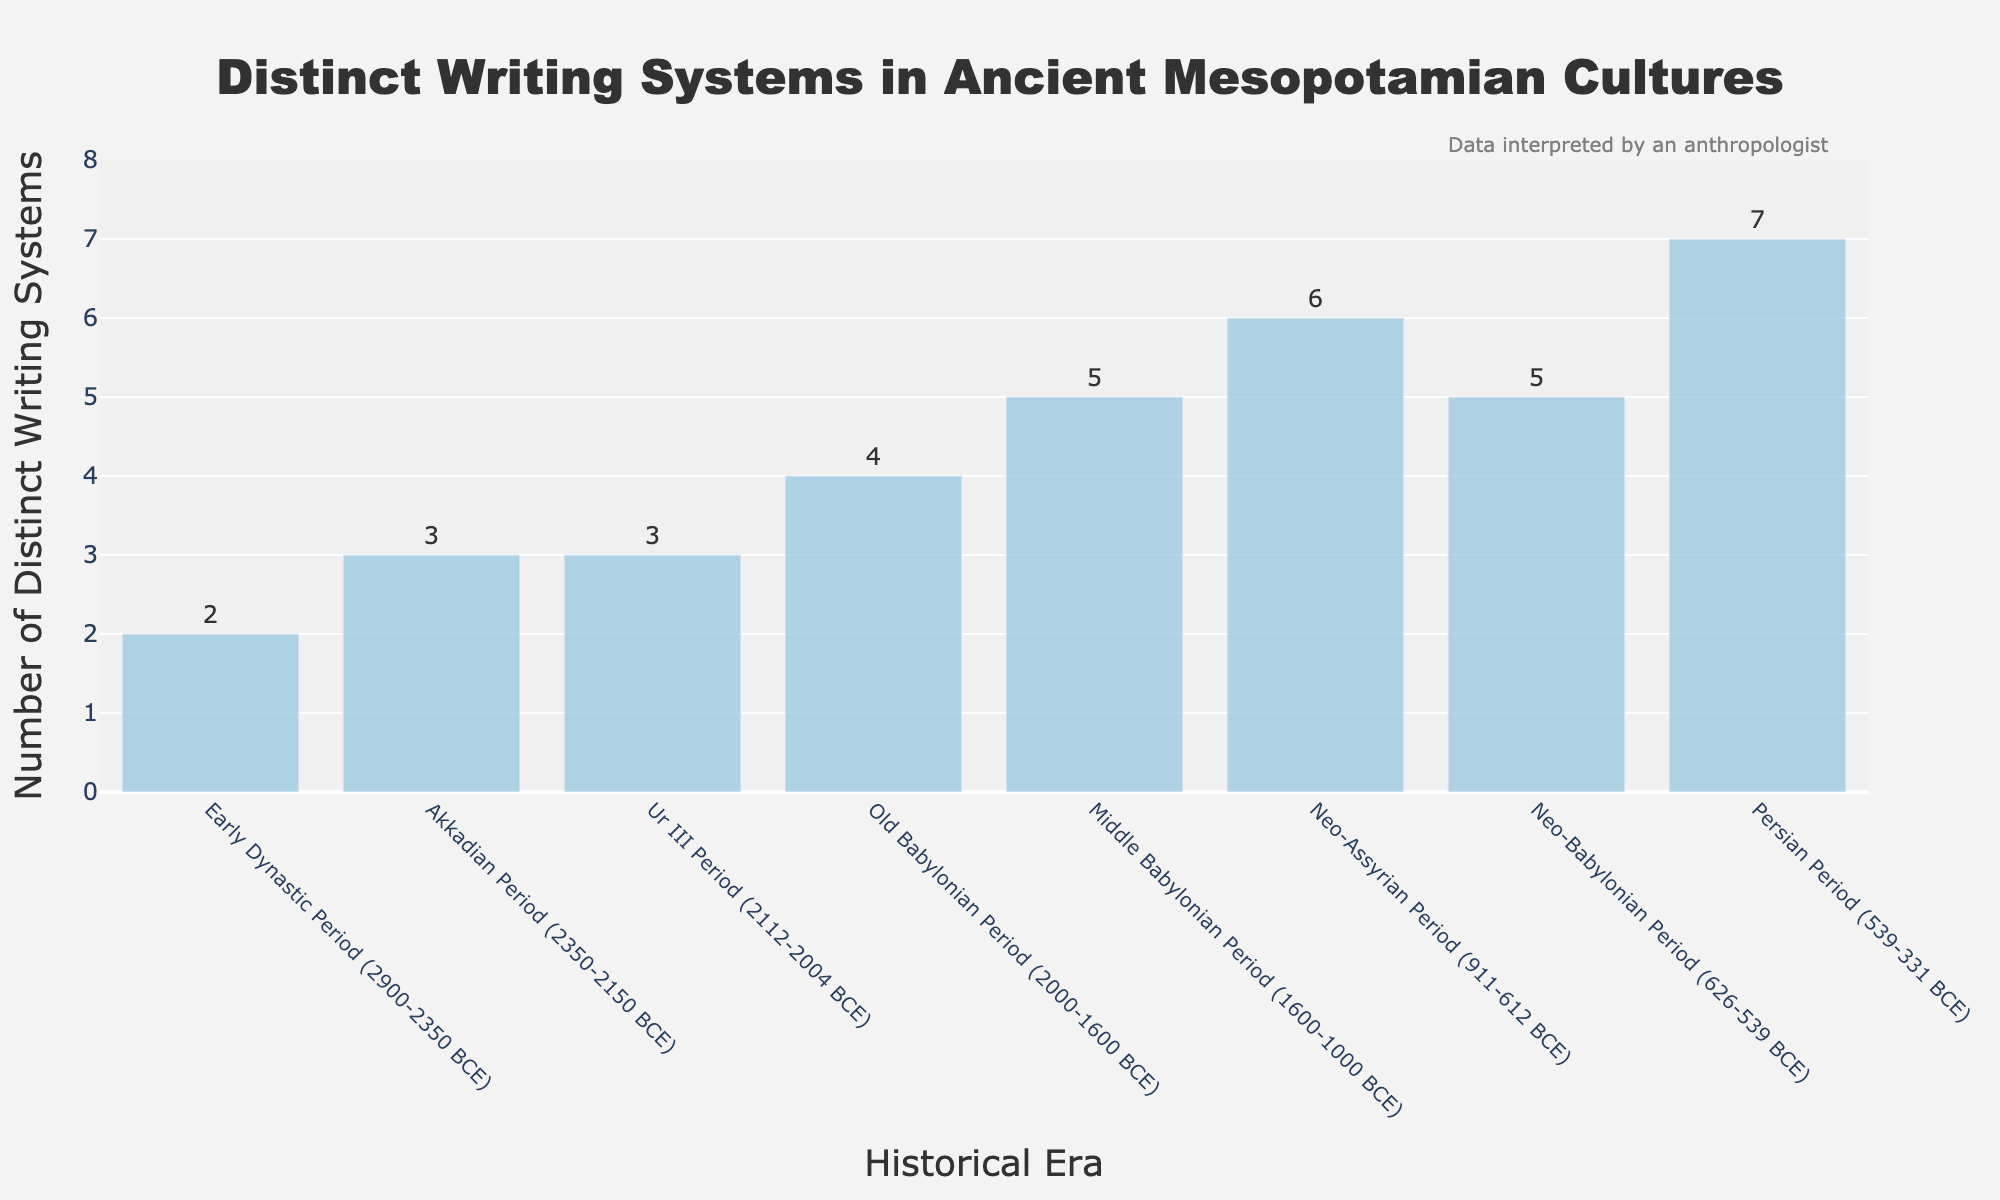What is the total number of distinct writing systems recorded across all historical eras? Add the number of distinct writing systems for all eras: 2 + 3 + 3 + 4 + 5 + 6 + 5 + 7 = 35
Answer: 35 Which historical era has the highest number of distinct writing systems? The Persian Period has the highest number of distinct writing systems with a count of 7, as indicated at its peak height on the chart.
Answer: Persian Period (539-331 BCE) How many more distinct writing systems were there in the Neo-Assyrian Period compared to the Early Dynastic Period? Subtract the number of writing systems in the Early Dynastic Period (2) from the Neo-Assyrian Period (6): 6 - 2 = 4
Answer: 4 Which eras have an equal number of distinct writing systems? The Akkadian Period and the Ur III Period both have 3 distinct writing systems, and the Middle Babylonian Period and the Neo-Babylonian Period both have 5.
Answer: Akkadian Period and Ur III Period; Middle Babylonian Period and Neo-Babylonian Period Is there any era where the number of distinct writing systems is exactly twice that of another era? Compare each number for twice the value of other eras: In the Old Babylonian Period (4) there are exactly twice as many writing systems as in the Early Dynastic Period (2).
Answer: Old Babylonian Period (2000-1600 BCE) and Early Dynastic Period (2900-2350 BCE) What is the average number of distinct writing systems across all historical eras? Sum the total number of writing systems (35) and divide by the number of eras (8): 35 / 8 = 4.375
Answer: 4.375 During which historical era did the number of distinct writing systems show the first visible increment from the previous era? The first increment occurs from the Early Dynastic Period (2) to the Akkadian Period (3).
Answer: Akkadian Period (2350-2150 BCE) Did the number of distinct writing systems increase, decrease, or remain the same from the Old Babylonian Period to the Middle Babylonian Period? The number increased from 4 in the Old Babylonian Period to 5 in the Middle Babylonian Period.
Answer: Increase What is the difference between the number of distinct writing systems in the Persian Period and the Ur III Period? Subtract the number of writing systems in the Ur III Period (3) from the Persian Period (7): 7 - 3 = 4
Answer: 4 Which historical era shows the largest increase in distinct writing systems compared to its preceding era? Compare the differences: Early Dynastic to Akkadian (+1), Akkadian to Ur III (+0), Ur III to Old Babylonian (+1), Old Babylonian to Middle Babylonian (+1), Middle Babylonian to Neo-Assyrian (+1), Neo-Assyrian to Neo-Babylonian (-1), Neo-Babylonian to Persian (+2). The Persian Period shows the largest increase.
Answer: Persian Period (539-331 BCE) 